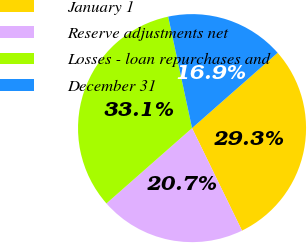Convert chart to OTSL. <chart><loc_0><loc_0><loc_500><loc_500><pie_chart><fcel>January 1<fcel>Reserve adjustments net<fcel>Losses - loan repurchases and<fcel>December 31<nl><fcel>29.27%<fcel>20.73%<fcel>33.13%<fcel>16.87%<nl></chart> 